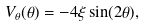<formula> <loc_0><loc_0><loc_500><loc_500>V _ { \theta } ( \theta ) = - 4 \xi \sin ( 2 \theta ) ,</formula> 